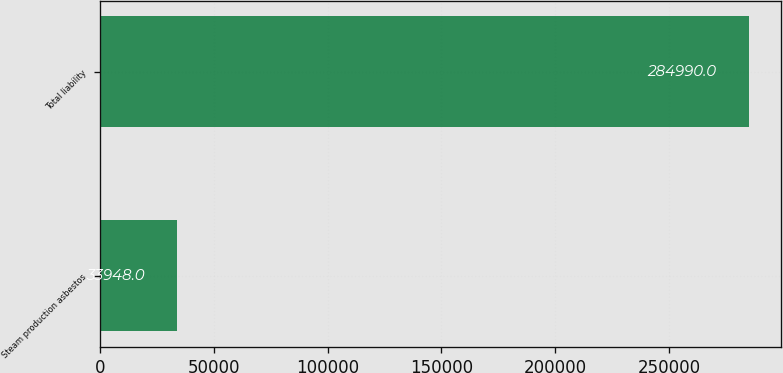Convert chart. <chart><loc_0><loc_0><loc_500><loc_500><bar_chart><fcel>Steam production asbestos<fcel>Total liability<nl><fcel>33948<fcel>284990<nl></chart> 